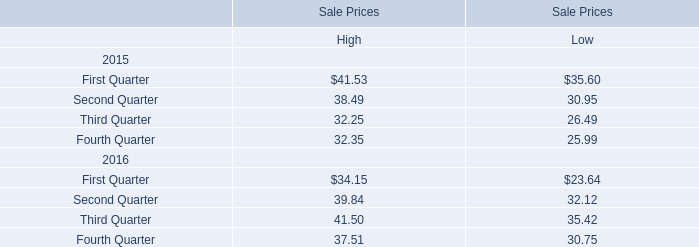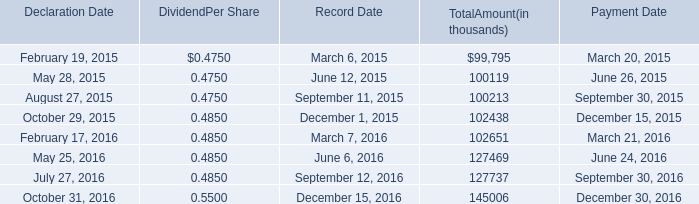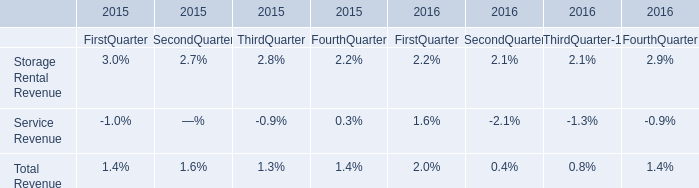What is the increasing rate of High for Sale Prices in Second Quarter between 2015 and 2016? 
Computations: ((39.84 - 38.49) / 38.49)
Answer: 0.03507. 